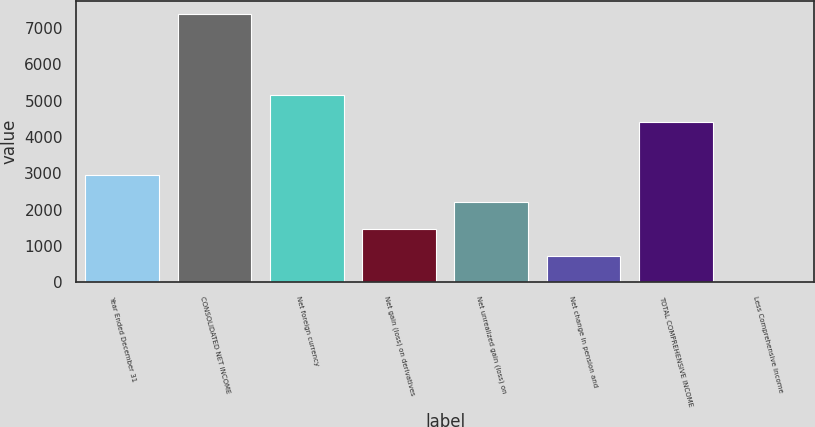<chart> <loc_0><loc_0><loc_500><loc_500><bar_chart><fcel>Year Ended December 31<fcel>CONSOLIDATED NET INCOME<fcel>Net foreign currency<fcel>Net gain (loss) on derivatives<fcel>Net unrealized gain (loss) on<fcel>Net change in pension and<fcel>TOTAL COMPREHENSIVE INCOME<fcel>Less Comprehensive income<nl><fcel>2948.2<fcel>7366<fcel>5157.1<fcel>1475.6<fcel>2211.9<fcel>739.3<fcel>4420.8<fcel>3<nl></chart> 